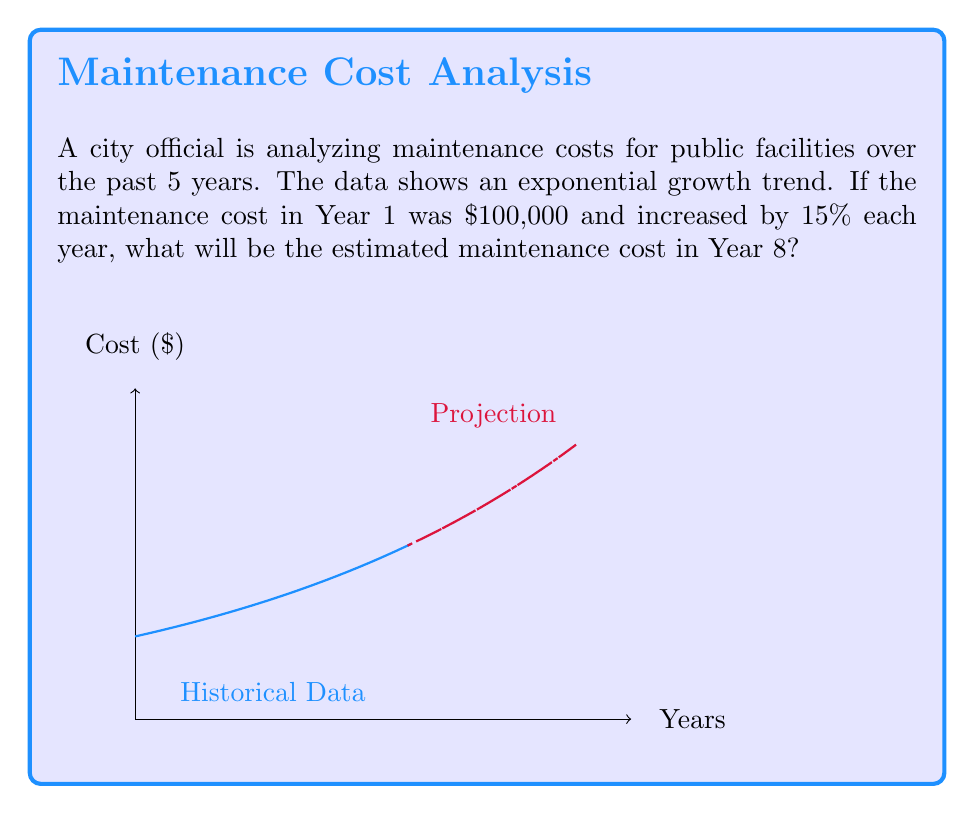Solve this math problem. Let's approach this step-by-step:

1) The initial cost (Year 1) is $100,000.

2) The annual increase is 15% or 0.15.

3) For exponential growth, we use the formula:
   $A = P(1 + r)^n$
   Where:
   $A$ = Final amount
   $P$ = Initial principal balance
   $r$ = Annual interest rate (in decimal form)
   $n$ = Number of years

4) In this case:
   $P = 100,000$
   $r = 0.15$
   $n = 8 - 1 = 7$ (because we're calculating for Year 8, which is 7 years after Year 1)

5) Plugging these values into our formula:
   $A = 100,000(1 + 0.15)^7$

6) Simplify:
   $A = 100,000(1.15)^7$

7) Calculate:
   $A = 100,000 * 2.6600$
   $A = 266,000$

Therefore, the estimated maintenance cost in Year 8 will be $266,000.
Answer: $266,000 